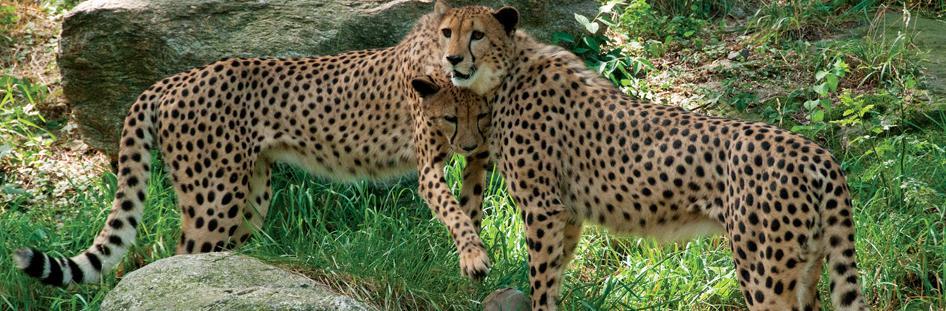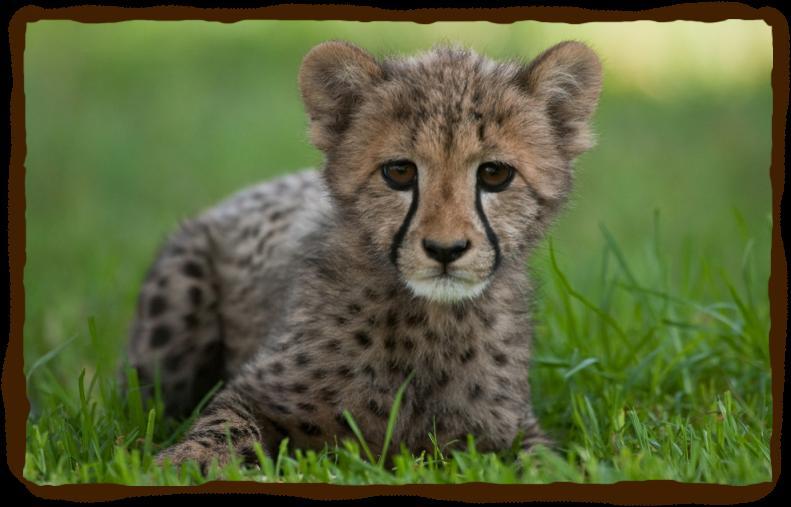The first image is the image on the left, the second image is the image on the right. Evaluate the accuracy of this statement regarding the images: "At least one of the animals is in mid-leap.". Is it true? Answer yes or no. No. 